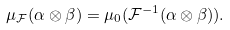Convert formula to latex. <formula><loc_0><loc_0><loc_500><loc_500>\mu _ { \mathcal { F } } ( \alpha \otimes \beta ) = \mu _ { 0 } ( \mathcal { F } ^ { - 1 } ( \alpha \otimes \beta ) ) .</formula> 